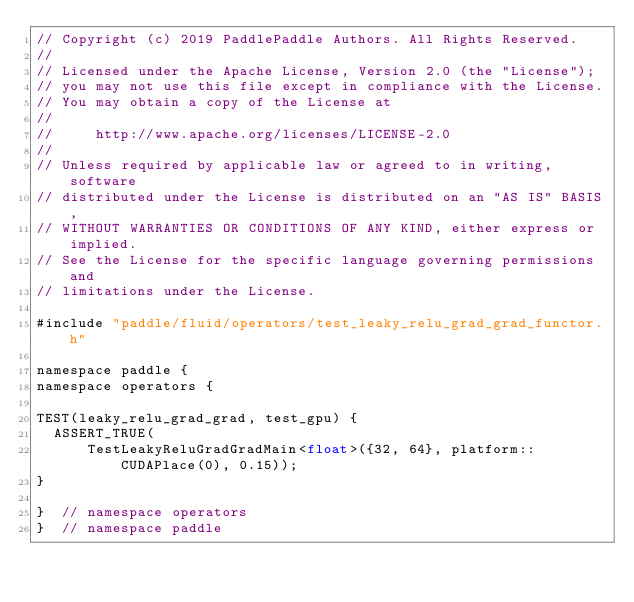<code> <loc_0><loc_0><loc_500><loc_500><_Cuda_>// Copyright (c) 2019 PaddlePaddle Authors. All Rights Reserved.
//
// Licensed under the Apache License, Version 2.0 (the "License");
// you may not use this file except in compliance with the License.
// You may obtain a copy of the License at
//
//     http://www.apache.org/licenses/LICENSE-2.0
//
// Unless required by applicable law or agreed to in writing, software
// distributed under the License is distributed on an "AS IS" BASIS,
// WITHOUT WARRANTIES OR CONDITIONS OF ANY KIND, either express or implied.
// See the License for the specific language governing permissions and
// limitations under the License.

#include "paddle/fluid/operators/test_leaky_relu_grad_grad_functor.h"

namespace paddle {
namespace operators {

TEST(leaky_relu_grad_grad, test_gpu) {
  ASSERT_TRUE(
      TestLeakyReluGradGradMain<float>({32, 64}, platform::CUDAPlace(0), 0.15));
}

}  // namespace operators
}  // namespace paddle
</code> 